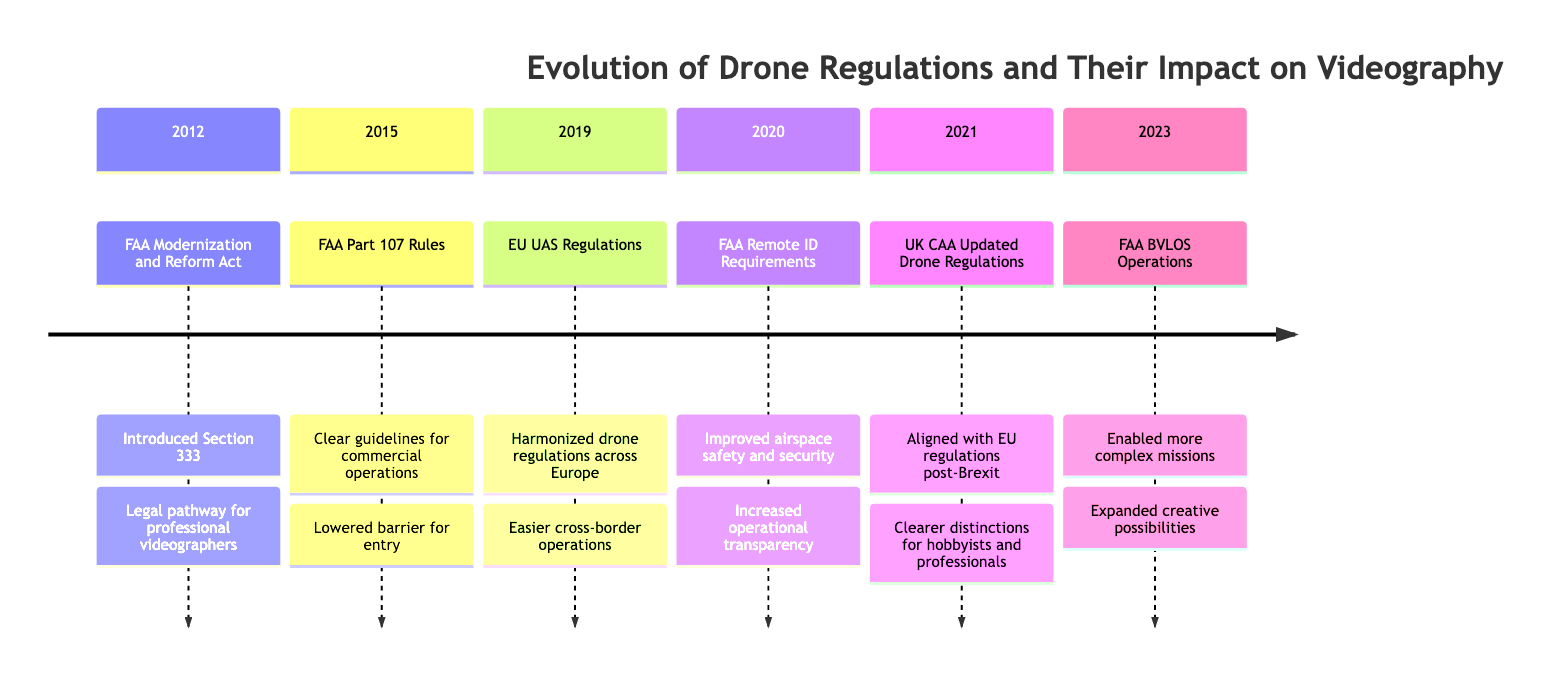What year was the FAA Modernization and Reform Act introduced? The diagram indicates that the FAA Modernization and Reform Act was introduced in 2012. This is the specific year shown next to the corresponding regulation change.
Answer: 2012 What was the impact of the FAA Part 107 Rules? According to the diagram, the impact of the FAA Part 107 Rules was that it lowered the barrier for entry into professional drone videography. This relates to how the regulation made it easier for individuals to start operations.
Answer: Lowered barrier for entry What reason led to the EU UAS Regulations in 2019? The diagram shows that the reason for the EU UAS Regulations was to harmonize drone regulations across Europe. This is the stated motivation for the introduction of this regulation.
Answer: Harmonize drone regulations How many significant regulatory changes are indicated in the diagram? By counting the elements in the timeline, it is clear that there are six significant regulatory changes indicated from 2012 to 2023. Each year represents one regulatory change, adding up to the total.
Answer: 6 Which regulation allowed certified pilots more freedom in drone videography operations? The FAA Beyond Visual Line of Sight (BVLOS) Operations regulation, introduced in 2023, is indicated in the diagram as allowing certified pilots more freedom in their drone operations. This reflects the regulatory enhancement for professional use.
Answer: FAA BVLOS Operations What was a key reason for the FAA Remote ID Requirements? The diagram states that the key reason for the FAA Remote ID Requirements was to improve airspace safety and security. This reason is directly associated with the implementation of this regulation.
Answer: Improve airspace safety and security What impact did the UK CAA Updated Drone Regulations have on hobbyist videographers? The diagram indicates that the impact of the UK CAA Updated Drone Regulations was to provide clearer distinctions and requirements for both hobbyist and professional videographers, thus ensuring safer and more compliant drone use. This directly addresses hobbyist operations.
Answer: Clearer distinctions for hobbyists What year did the EU UAS Regulations come into effect? The diagram specifies that the EU UAS Regulations came into effect in 2019, which highlights that year as the introduction of unified standards across Europe.
Answer: 2019 What was introduced by the FAA Modernization and Reform Act that benefited professional videographers? The diagram indicates that the FAA Modernization and Reform Act introduced Section 333, which created a legal pathway for professional videographers to use drones. This reflects the specific benefit provided by this regulation.
Answer: Section 333 